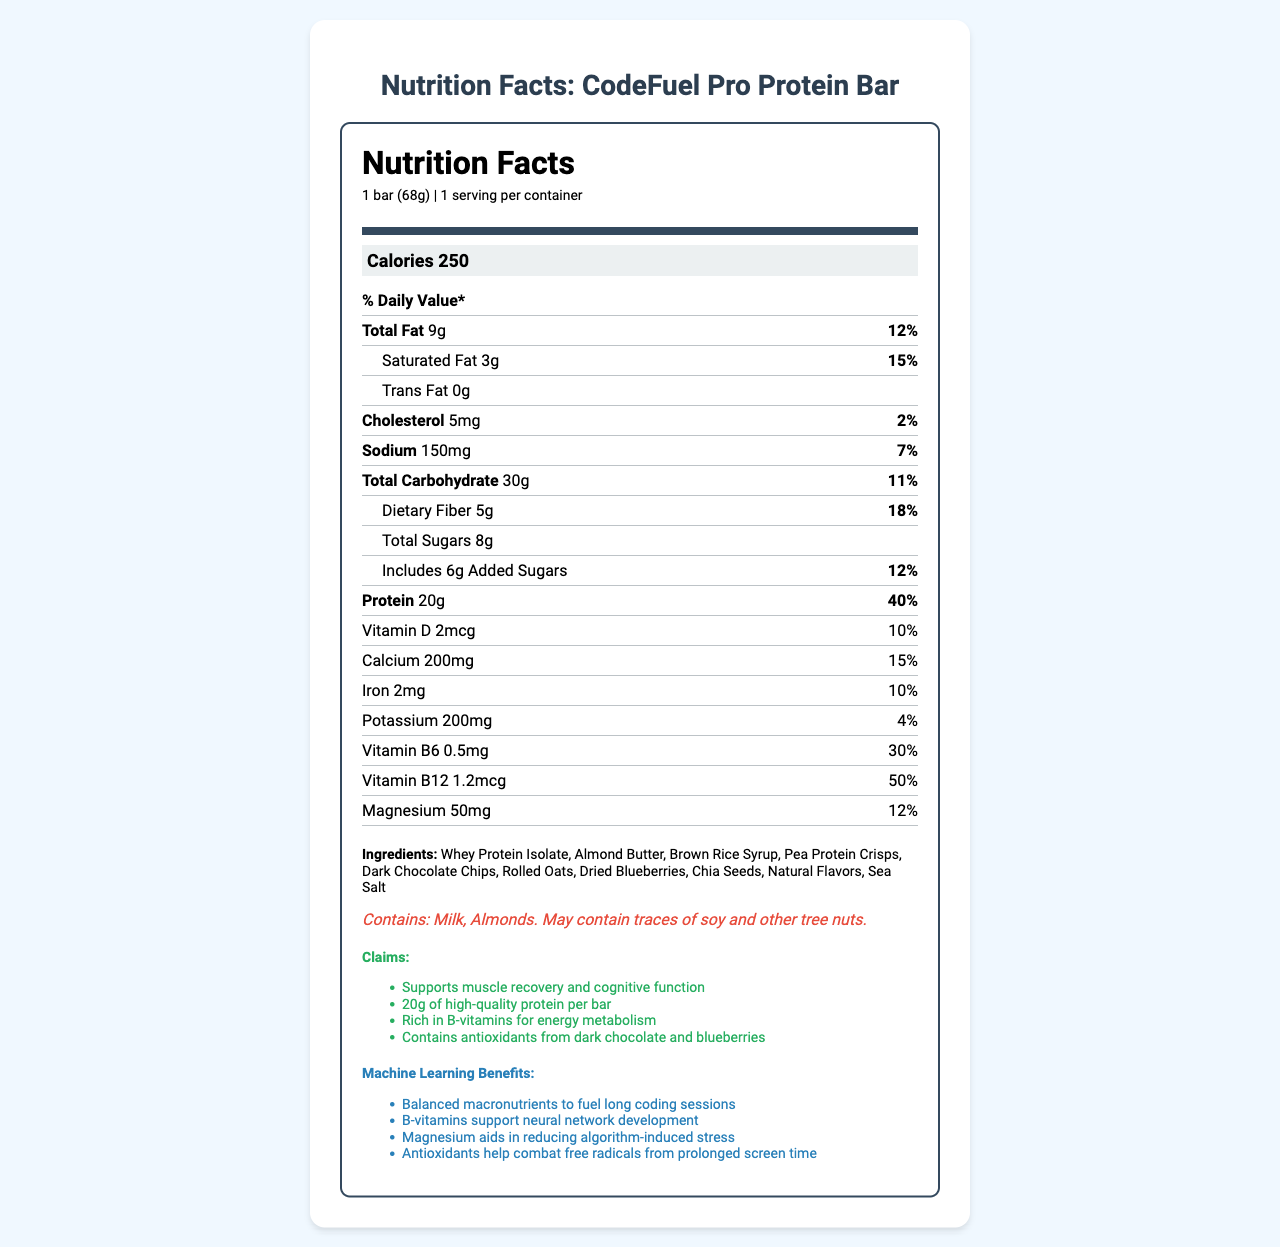what is the calorie count per serving? The document lists the calorie content per serving as 250 calories.
Answer: 250 calories how much protein does the CodeFuel Pro Protein Bar provide? The document specifies that there is 20g of protein per serving, which is one bar.
Answer: 20g what percentage of the daily value of dietary fiber is in one serving? The document shows that one serving contains 5g of dietary fiber, which is 18% of the daily value.
Answer: 18% what are the first three ingredients listed? The ingredients are listed in the document, and the first three are Whey Protein Isolate, Almond Butter, and Brown Rice Syrup.
Answer: Whey Protein Isolate, Almond Butter, Brown Rice Syrup what is the daily value percentage of Vitamin B12 in the bar? The document lists the daily value percentage for Vitamin B12 as 50%.
Answer: 50% how much total fat is in the CodeFuel Pro Protein Bar? The document lists total fat content as 9g.
Answer: 9g what is the amount of sugars in the bar? The document specifies that the total amount of sugars in the bar is 8g.
Answer: 8g which of the following is a major ingredient in the bar? A. Peanuts B. Whey Protein Isolate C. Soy Protein Isolate The ingredients section lists Whey Protein Isolate as an ingredient, but not peanuts or soy protein isolate.
Answer: B. Whey Protein Isolate how much calcium does one bar provide? A. 100mg B. 200mg C. 300mg According to the document, the calcium content per serving is 200mg.
Answer: B. 200mg is there any trans fat in the CodeFuel Pro Protein Bar? The document lists the amount of trans fat as 0g.
Answer: No are there any allergens in this bar? If so, what are they? The allergen information section mentions that the bar contains Milk and Almonds, and may contain traces of soy and other tree nuts.
Answer: Yes, Milk and Almonds does the bar contain Chia Seeds? The list of ingredients includes Chia Seeds.
Answer: Yes what are the claims made about the bar's benefits? The document lists these claims in the claim statements section.
Answer: Supports muscle recovery and cognitive function, 20g of high-quality protein per bar, Rich in B-vitamins for energy metabolism, Contains antioxidants from dark chocolate and blueberries what is the daily value percentage of saturated fat? The document shows that the saturated fat content gives 15% of the daily value.
Answer: 15% summarize the information provided in the document. The document comprehensively details the nutrition facts, serving size, caloric content, macronutrient breakdown, ingredients, allergen warnings, and health benefit claims of the CodeFuel Pro Protein Bar. Specifically, it highlights the bar's protein content and vitamin and mineral benefits that support both physical and cognitive function.
Answer: The CodeFuel Pro Protein Bar's nutrition facts, ingredients, allergens, and health claims are presented. The bar contains 250 calories, 20g protein, and essential vitamins and minerals to support muscle recovery and cognitive function. It’s designed to fuel long coding sessions, reduce stress, and combat free radicals. The ingredients include Whey Protein Isolate, Almond Butter, and more, with allergen info showing it contains Milk and Almonds. what is the price of the CodeFuel Pro Protein Bar? The document does not provide any information regarding the price of the product.
Answer: Cannot be determined 